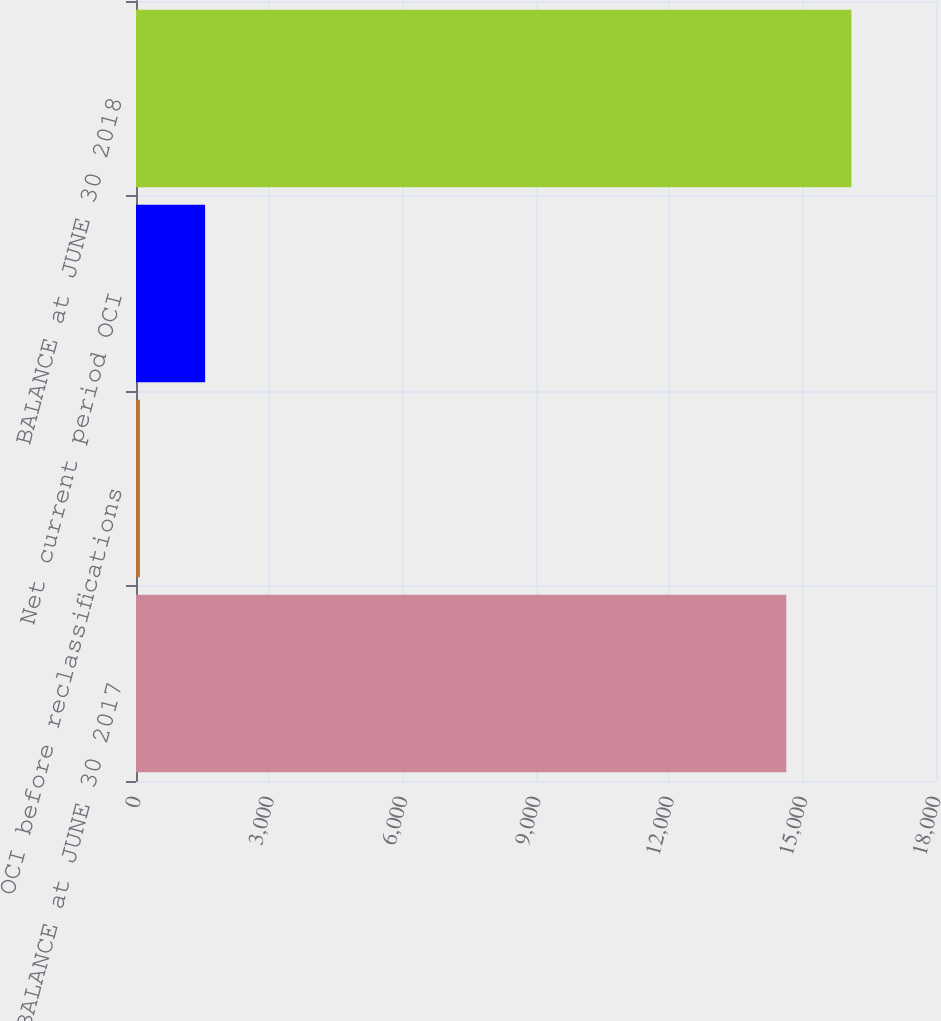Convert chart. <chart><loc_0><loc_0><loc_500><loc_500><bar_chart><fcel>BALANCE at JUNE 30 2017<fcel>OCI before reclassifications<fcel>Net current period OCI<fcel>BALANCE at JUNE 30 2018<nl><fcel>14632<fcel>89<fcel>1555<fcel>16098<nl></chart> 